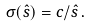Convert formula to latex. <formula><loc_0><loc_0><loc_500><loc_500>\sigma ( \hat { s } ) = c / \hat { s } \, .</formula> 